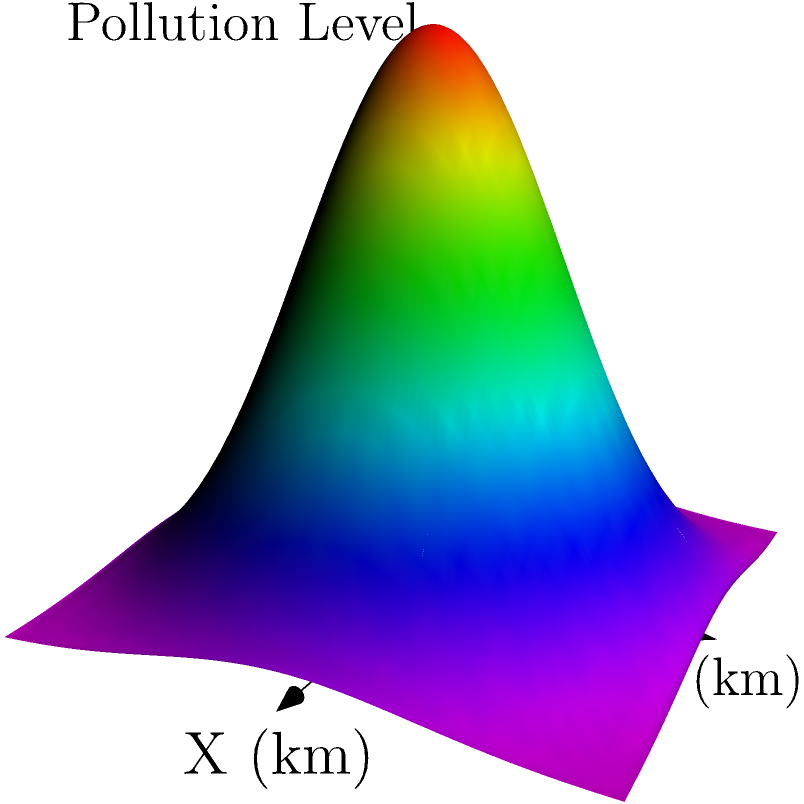In the 3D coordinate system shown above, air pollution data is visualized for an urban area. The X and Y axes represent distances in kilometers from the urban center, while the Z-axis represents the pollution level. What does the shape of the surface suggest about the distribution of air pollution in this urban area? To interpret the air pollution distribution from the 3D visualization:

1. Observe the overall shape: The surface forms a bell-shaped curve or dome.

2. Analyze the center: The highest point of the dome is at (0,0), which represents the urban center.

3. Examine the gradient: The pollution level decreases as we move away from the center in any direction.

4. Consider the symmetry: The dome appears roughly symmetrical, suggesting similar pollution dispersion in all directions.

5. Interpret the colors: The color gradient from red (center) to blue (edges) reinforces the decrease in pollution levels from the center outwards.

6. Mathematical representation: The surface resembles an exponential decay function in two dimensions, which can be expressed as:

   $$z = A \cdot e^{-k(x^2 + y^2)}$$

   Where $A$ is the maximum pollution level at the center, and $k$ is a decay constant.

This visualization suggests that air pollution is highest in the urban center and decreases exponentially as we move away from the center, forming a radial pattern of pollution distribution.
Answer: Exponential decay of pollution levels radiating outward from the urban center 